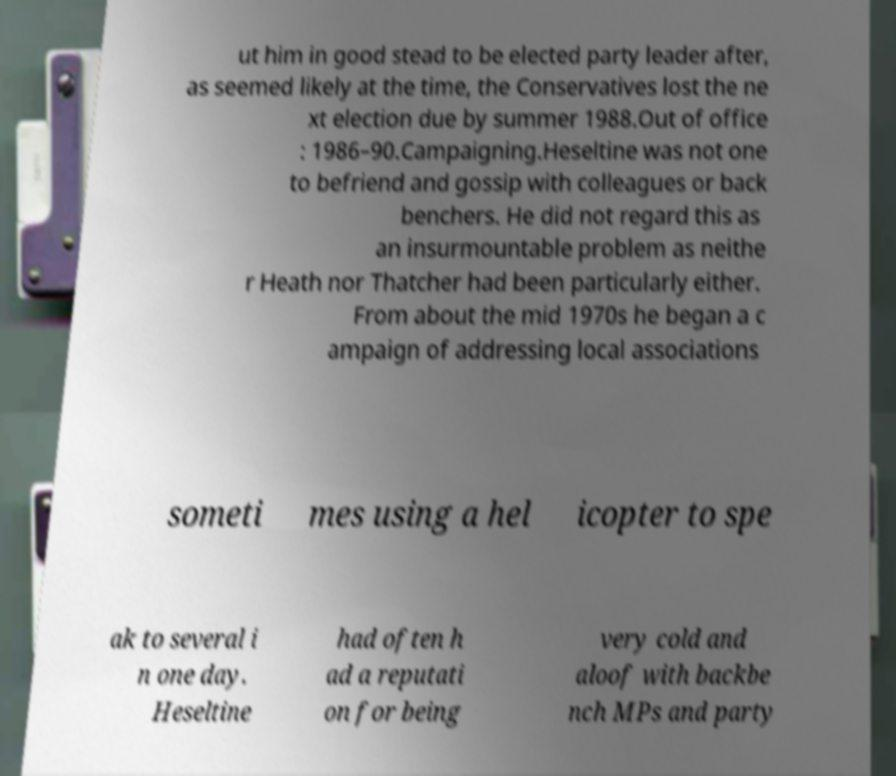What messages or text are displayed in this image? I need them in a readable, typed format. ut him in good stead to be elected party leader after, as seemed likely at the time, the Conservatives lost the ne xt election due by summer 1988.Out of office : 1986–90.Campaigning.Heseltine was not one to befriend and gossip with colleagues or back benchers. He did not regard this as an insurmountable problem as neithe r Heath nor Thatcher had been particularly either. From about the mid 1970s he began a c ampaign of addressing local associations someti mes using a hel icopter to spe ak to several i n one day. Heseltine had often h ad a reputati on for being very cold and aloof with backbe nch MPs and party 